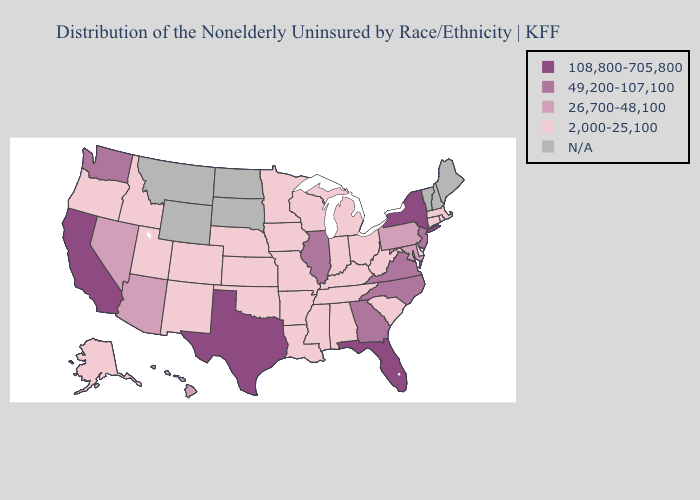Does Nevada have the lowest value in the USA?
Be succinct. No. Does Virginia have the lowest value in the USA?
Concise answer only. No. Name the states that have a value in the range N/A?
Write a very short answer. Maine, Montana, New Hampshire, North Dakota, South Dakota, Vermont, Wyoming. How many symbols are there in the legend?
Keep it brief. 5. Which states have the lowest value in the USA?
Quick response, please. Alabama, Alaska, Arkansas, Colorado, Connecticut, Delaware, Idaho, Indiana, Iowa, Kansas, Kentucky, Louisiana, Massachusetts, Michigan, Minnesota, Mississippi, Missouri, Nebraska, New Mexico, Ohio, Oklahoma, Oregon, Rhode Island, South Carolina, Tennessee, Utah, West Virginia, Wisconsin. What is the highest value in the USA?
Answer briefly. 108,800-705,800. Among the states that border Idaho , does Utah have the lowest value?
Answer briefly. Yes. Name the states that have a value in the range 26,700-48,100?
Short answer required. Arizona, Hawaii, Maryland, Nevada, Pennsylvania. Does the first symbol in the legend represent the smallest category?
Answer briefly. No. Which states have the lowest value in the Northeast?
Give a very brief answer. Connecticut, Massachusetts, Rhode Island. Does Michigan have the highest value in the USA?
Short answer required. No. Name the states that have a value in the range 26,700-48,100?
Be succinct. Arizona, Hawaii, Maryland, Nevada, Pennsylvania. What is the lowest value in the USA?
Write a very short answer. 2,000-25,100. Name the states that have a value in the range 108,800-705,800?
Short answer required. California, Florida, New York, Texas. Which states have the lowest value in the USA?
Quick response, please. Alabama, Alaska, Arkansas, Colorado, Connecticut, Delaware, Idaho, Indiana, Iowa, Kansas, Kentucky, Louisiana, Massachusetts, Michigan, Minnesota, Mississippi, Missouri, Nebraska, New Mexico, Ohio, Oklahoma, Oregon, Rhode Island, South Carolina, Tennessee, Utah, West Virginia, Wisconsin. 